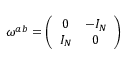Convert formula to latex. <formula><loc_0><loc_0><loc_500><loc_500>\omega ^ { a b } = \left ( \begin{array} { c c } { 0 } & { { - I _ { N } } } \\ { { I _ { N } } } & { 0 } \end{array} \right )</formula> 